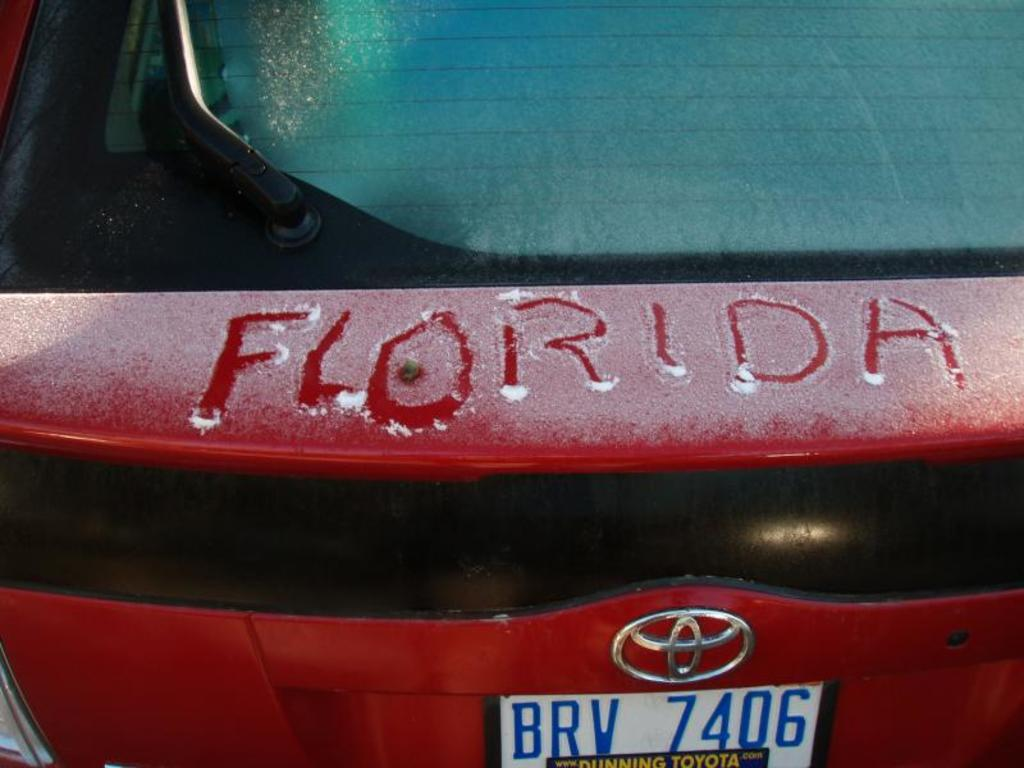Provide a one-sentence caption for the provided image. Florida is traced in the snow that is on a red car. 